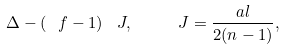<formula> <loc_0><loc_0><loc_500><loc_500>\Delta - \left ( \ f - 1 \right ) \ J , \quad \ J = \frac { a l } { 2 ( n - 1 ) } ,</formula> 